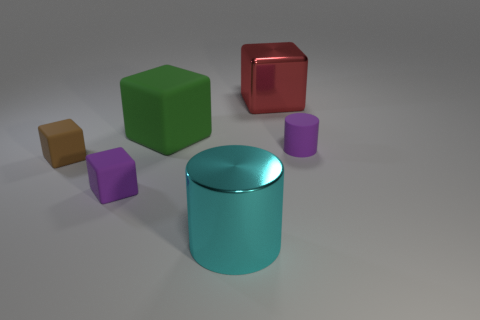Are there any other purple cubes that have the same material as the purple block?
Provide a succinct answer. No. What color is the metal thing in front of the small purple object that is on the right side of the rubber block that is behind the tiny brown cube?
Make the answer very short. Cyan. Is the color of the cylinder right of the big red metallic object the same as the tiny block that is to the right of the small brown thing?
Give a very brief answer. Yes. Are there any other things that are the same color as the large matte object?
Give a very brief answer. No. Is the number of small purple objects to the left of the big cylinder less than the number of tiny brown cubes?
Your answer should be compact. No. What number of tiny matte cubes are there?
Your answer should be very brief. 2. Does the big red object have the same shape as the small purple object that is right of the small purple block?
Your answer should be very brief. No. Is the number of red objects that are in front of the large cyan metallic cylinder less than the number of things that are behind the tiny brown rubber cube?
Provide a short and direct response. Yes. Is the shape of the large red object the same as the brown thing?
Your response must be concise. Yes. The red shiny cube is what size?
Offer a terse response. Large. 